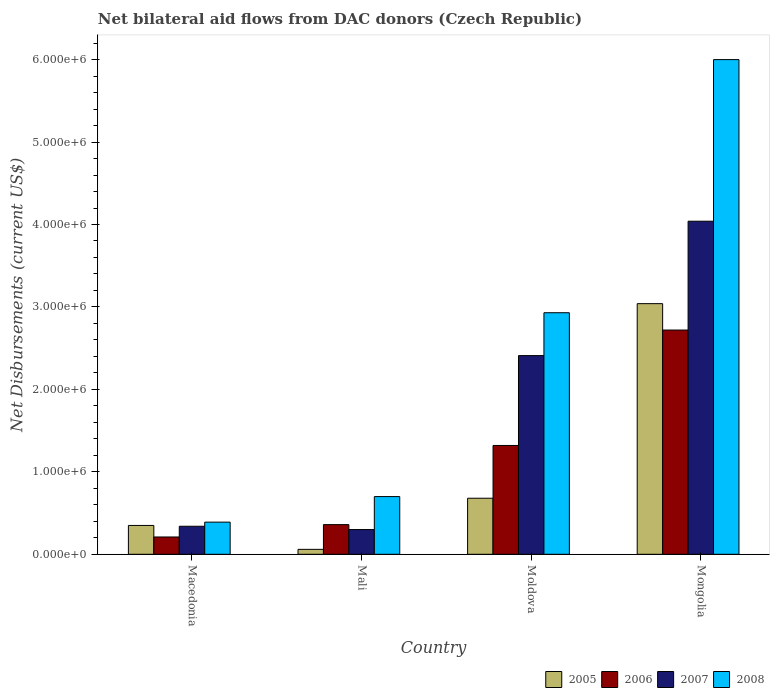How many groups of bars are there?
Give a very brief answer. 4. Are the number of bars per tick equal to the number of legend labels?
Your answer should be compact. Yes. Are the number of bars on each tick of the X-axis equal?
Keep it short and to the point. Yes. How many bars are there on the 1st tick from the left?
Your answer should be very brief. 4. How many bars are there on the 3rd tick from the right?
Ensure brevity in your answer.  4. What is the label of the 2nd group of bars from the left?
Your answer should be very brief. Mali. What is the net bilateral aid flows in 2005 in Macedonia?
Make the answer very short. 3.50e+05. Across all countries, what is the maximum net bilateral aid flows in 2007?
Make the answer very short. 4.04e+06. In which country was the net bilateral aid flows in 2007 maximum?
Your answer should be very brief. Mongolia. In which country was the net bilateral aid flows in 2006 minimum?
Your answer should be compact. Macedonia. What is the total net bilateral aid flows in 2008 in the graph?
Offer a terse response. 1.00e+07. What is the difference between the net bilateral aid flows in 2005 in Moldova and that in Mongolia?
Offer a terse response. -2.36e+06. What is the difference between the net bilateral aid flows in 2007 in Macedonia and the net bilateral aid flows in 2006 in Moldova?
Provide a succinct answer. -9.80e+05. What is the average net bilateral aid flows in 2005 per country?
Ensure brevity in your answer.  1.03e+06. What is the difference between the net bilateral aid flows of/in 2005 and net bilateral aid flows of/in 2006 in Moldova?
Provide a short and direct response. -6.40e+05. In how many countries, is the net bilateral aid flows in 2005 greater than 5600000 US$?
Provide a short and direct response. 0. What is the ratio of the net bilateral aid flows in 2006 in Moldova to that in Mongolia?
Offer a terse response. 0.49. Is the difference between the net bilateral aid flows in 2005 in Macedonia and Mongolia greater than the difference between the net bilateral aid flows in 2006 in Macedonia and Mongolia?
Give a very brief answer. No. What is the difference between the highest and the second highest net bilateral aid flows in 2007?
Your answer should be very brief. 1.63e+06. What is the difference between the highest and the lowest net bilateral aid flows in 2005?
Your answer should be very brief. 2.98e+06. Is the sum of the net bilateral aid flows in 2008 in Mali and Mongolia greater than the maximum net bilateral aid flows in 2006 across all countries?
Provide a short and direct response. Yes. What does the 1st bar from the left in Mongolia represents?
Provide a succinct answer. 2005. Is it the case that in every country, the sum of the net bilateral aid flows in 2006 and net bilateral aid flows in 2005 is greater than the net bilateral aid flows in 2008?
Provide a short and direct response. No. Are all the bars in the graph horizontal?
Provide a succinct answer. No. How many countries are there in the graph?
Your response must be concise. 4. What is the difference between two consecutive major ticks on the Y-axis?
Your answer should be compact. 1.00e+06. Where does the legend appear in the graph?
Your answer should be very brief. Bottom right. How many legend labels are there?
Offer a very short reply. 4. What is the title of the graph?
Offer a terse response. Net bilateral aid flows from DAC donors (Czech Republic). What is the label or title of the Y-axis?
Give a very brief answer. Net Disbursements (current US$). What is the Net Disbursements (current US$) of 2006 in Macedonia?
Your response must be concise. 2.10e+05. What is the Net Disbursements (current US$) in 2005 in Mali?
Your answer should be compact. 6.00e+04. What is the Net Disbursements (current US$) of 2006 in Mali?
Your response must be concise. 3.60e+05. What is the Net Disbursements (current US$) in 2007 in Mali?
Offer a terse response. 3.00e+05. What is the Net Disbursements (current US$) of 2008 in Mali?
Give a very brief answer. 7.00e+05. What is the Net Disbursements (current US$) of 2005 in Moldova?
Offer a very short reply. 6.80e+05. What is the Net Disbursements (current US$) of 2006 in Moldova?
Offer a very short reply. 1.32e+06. What is the Net Disbursements (current US$) in 2007 in Moldova?
Your answer should be compact. 2.41e+06. What is the Net Disbursements (current US$) of 2008 in Moldova?
Your answer should be very brief. 2.93e+06. What is the Net Disbursements (current US$) of 2005 in Mongolia?
Your response must be concise. 3.04e+06. What is the Net Disbursements (current US$) of 2006 in Mongolia?
Provide a short and direct response. 2.72e+06. What is the Net Disbursements (current US$) in 2007 in Mongolia?
Make the answer very short. 4.04e+06. What is the Net Disbursements (current US$) of 2008 in Mongolia?
Provide a short and direct response. 6.00e+06. Across all countries, what is the maximum Net Disbursements (current US$) in 2005?
Your response must be concise. 3.04e+06. Across all countries, what is the maximum Net Disbursements (current US$) in 2006?
Give a very brief answer. 2.72e+06. Across all countries, what is the maximum Net Disbursements (current US$) of 2007?
Keep it short and to the point. 4.04e+06. Across all countries, what is the minimum Net Disbursements (current US$) of 2005?
Your response must be concise. 6.00e+04. Across all countries, what is the minimum Net Disbursements (current US$) of 2007?
Your answer should be very brief. 3.00e+05. Across all countries, what is the minimum Net Disbursements (current US$) in 2008?
Keep it short and to the point. 3.90e+05. What is the total Net Disbursements (current US$) in 2005 in the graph?
Offer a terse response. 4.13e+06. What is the total Net Disbursements (current US$) of 2006 in the graph?
Your answer should be compact. 4.61e+06. What is the total Net Disbursements (current US$) of 2007 in the graph?
Your answer should be compact. 7.09e+06. What is the total Net Disbursements (current US$) in 2008 in the graph?
Provide a short and direct response. 1.00e+07. What is the difference between the Net Disbursements (current US$) of 2007 in Macedonia and that in Mali?
Provide a succinct answer. 4.00e+04. What is the difference between the Net Disbursements (current US$) of 2008 in Macedonia and that in Mali?
Provide a short and direct response. -3.10e+05. What is the difference between the Net Disbursements (current US$) of 2005 in Macedonia and that in Moldova?
Provide a succinct answer. -3.30e+05. What is the difference between the Net Disbursements (current US$) in 2006 in Macedonia and that in Moldova?
Provide a succinct answer. -1.11e+06. What is the difference between the Net Disbursements (current US$) of 2007 in Macedonia and that in Moldova?
Make the answer very short. -2.07e+06. What is the difference between the Net Disbursements (current US$) of 2008 in Macedonia and that in Moldova?
Keep it short and to the point. -2.54e+06. What is the difference between the Net Disbursements (current US$) in 2005 in Macedonia and that in Mongolia?
Ensure brevity in your answer.  -2.69e+06. What is the difference between the Net Disbursements (current US$) in 2006 in Macedonia and that in Mongolia?
Keep it short and to the point. -2.51e+06. What is the difference between the Net Disbursements (current US$) of 2007 in Macedonia and that in Mongolia?
Make the answer very short. -3.70e+06. What is the difference between the Net Disbursements (current US$) in 2008 in Macedonia and that in Mongolia?
Your answer should be compact. -5.61e+06. What is the difference between the Net Disbursements (current US$) in 2005 in Mali and that in Moldova?
Ensure brevity in your answer.  -6.20e+05. What is the difference between the Net Disbursements (current US$) of 2006 in Mali and that in Moldova?
Your answer should be very brief. -9.60e+05. What is the difference between the Net Disbursements (current US$) in 2007 in Mali and that in Moldova?
Provide a short and direct response. -2.11e+06. What is the difference between the Net Disbursements (current US$) of 2008 in Mali and that in Moldova?
Your answer should be compact. -2.23e+06. What is the difference between the Net Disbursements (current US$) in 2005 in Mali and that in Mongolia?
Keep it short and to the point. -2.98e+06. What is the difference between the Net Disbursements (current US$) of 2006 in Mali and that in Mongolia?
Your answer should be very brief. -2.36e+06. What is the difference between the Net Disbursements (current US$) of 2007 in Mali and that in Mongolia?
Provide a short and direct response. -3.74e+06. What is the difference between the Net Disbursements (current US$) of 2008 in Mali and that in Mongolia?
Provide a succinct answer. -5.30e+06. What is the difference between the Net Disbursements (current US$) in 2005 in Moldova and that in Mongolia?
Provide a short and direct response. -2.36e+06. What is the difference between the Net Disbursements (current US$) of 2006 in Moldova and that in Mongolia?
Give a very brief answer. -1.40e+06. What is the difference between the Net Disbursements (current US$) in 2007 in Moldova and that in Mongolia?
Ensure brevity in your answer.  -1.63e+06. What is the difference between the Net Disbursements (current US$) in 2008 in Moldova and that in Mongolia?
Your answer should be very brief. -3.07e+06. What is the difference between the Net Disbursements (current US$) in 2005 in Macedonia and the Net Disbursements (current US$) in 2008 in Mali?
Give a very brief answer. -3.50e+05. What is the difference between the Net Disbursements (current US$) of 2006 in Macedonia and the Net Disbursements (current US$) of 2008 in Mali?
Keep it short and to the point. -4.90e+05. What is the difference between the Net Disbursements (current US$) of 2007 in Macedonia and the Net Disbursements (current US$) of 2008 in Mali?
Ensure brevity in your answer.  -3.60e+05. What is the difference between the Net Disbursements (current US$) of 2005 in Macedonia and the Net Disbursements (current US$) of 2006 in Moldova?
Your response must be concise. -9.70e+05. What is the difference between the Net Disbursements (current US$) in 2005 in Macedonia and the Net Disbursements (current US$) in 2007 in Moldova?
Your answer should be very brief. -2.06e+06. What is the difference between the Net Disbursements (current US$) in 2005 in Macedonia and the Net Disbursements (current US$) in 2008 in Moldova?
Offer a very short reply. -2.58e+06. What is the difference between the Net Disbursements (current US$) in 2006 in Macedonia and the Net Disbursements (current US$) in 2007 in Moldova?
Provide a succinct answer. -2.20e+06. What is the difference between the Net Disbursements (current US$) of 2006 in Macedonia and the Net Disbursements (current US$) of 2008 in Moldova?
Keep it short and to the point. -2.72e+06. What is the difference between the Net Disbursements (current US$) of 2007 in Macedonia and the Net Disbursements (current US$) of 2008 in Moldova?
Give a very brief answer. -2.59e+06. What is the difference between the Net Disbursements (current US$) in 2005 in Macedonia and the Net Disbursements (current US$) in 2006 in Mongolia?
Your response must be concise. -2.37e+06. What is the difference between the Net Disbursements (current US$) of 2005 in Macedonia and the Net Disbursements (current US$) of 2007 in Mongolia?
Your answer should be compact. -3.69e+06. What is the difference between the Net Disbursements (current US$) in 2005 in Macedonia and the Net Disbursements (current US$) in 2008 in Mongolia?
Your answer should be compact. -5.65e+06. What is the difference between the Net Disbursements (current US$) in 2006 in Macedonia and the Net Disbursements (current US$) in 2007 in Mongolia?
Your answer should be compact. -3.83e+06. What is the difference between the Net Disbursements (current US$) in 2006 in Macedonia and the Net Disbursements (current US$) in 2008 in Mongolia?
Keep it short and to the point. -5.79e+06. What is the difference between the Net Disbursements (current US$) of 2007 in Macedonia and the Net Disbursements (current US$) of 2008 in Mongolia?
Offer a terse response. -5.66e+06. What is the difference between the Net Disbursements (current US$) of 2005 in Mali and the Net Disbursements (current US$) of 2006 in Moldova?
Provide a short and direct response. -1.26e+06. What is the difference between the Net Disbursements (current US$) in 2005 in Mali and the Net Disbursements (current US$) in 2007 in Moldova?
Offer a very short reply. -2.35e+06. What is the difference between the Net Disbursements (current US$) in 2005 in Mali and the Net Disbursements (current US$) in 2008 in Moldova?
Make the answer very short. -2.87e+06. What is the difference between the Net Disbursements (current US$) of 2006 in Mali and the Net Disbursements (current US$) of 2007 in Moldova?
Make the answer very short. -2.05e+06. What is the difference between the Net Disbursements (current US$) in 2006 in Mali and the Net Disbursements (current US$) in 2008 in Moldova?
Your answer should be compact. -2.57e+06. What is the difference between the Net Disbursements (current US$) of 2007 in Mali and the Net Disbursements (current US$) of 2008 in Moldova?
Make the answer very short. -2.63e+06. What is the difference between the Net Disbursements (current US$) in 2005 in Mali and the Net Disbursements (current US$) in 2006 in Mongolia?
Your answer should be compact. -2.66e+06. What is the difference between the Net Disbursements (current US$) in 2005 in Mali and the Net Disbursements (current US$) in 2007 in Mongolia?
Make the answer very short. -3.98e+06. What is the difference between the Net Disbursements (current US$) of 2005 in Mali and the Net Disbursements (current US$) of 2008 in Mongolia?
Your answer should be compact. -5.94e+06. What is the difference between the Net Disbursements (current US$) of 2006 in Mali and the Net Disbursements (current US$) of 2007 in Mongolia?
Provide a succinct answer. -3.68e+06. What is the difference between the Net Disbursements (current US$) of 2006 in Mali and the Net Disbursements (current US$) of 2008 in Mongolia?
Offer a terse response. -5.64e+06. What is the difference between the Net Disbursements (current US$) in 2007 in Mali and the Net Disbursements (current US$) in 2008 in Mongolia?
Your response must be concise. -5.70e+06. What is the difference between the Net Disbursements (current US$) in 2005 in Moldova and the Net Disbursements (current US$) in 2006 in Mongolia?
Your answer should be very brief. -2.04e+06. What is the difference between the Net Disbursements (current US$) of 2005 in Moldova and the Net Disbursements (current US$) of 2007 in Mongolia?
Keep it short and to the point. -3.36e+06. What is the difference between the Net Disbursements (current US$) in 2005 in Moldova and the Net Disbursements (current US$) in 2008 in Mongolia?
Your answer should be very brief. -5.32e+06. What is the difference between the Net Disbursements (current US$) of 2006 in Moldova and the Net Disbursements (current US$) of 2007 in Mongolia?
Provide a succinct answer. -2.72e+06. What is the difference between the Net Disbursements (current US$) of 2006 in Moldova and the Net Disbursements (current US$) of 2008 in Mongolia?
Give a very brief answer. -4.68e+06. What is the difference between the Net Disbursements (current US$) of 2007 in Moldova and the Net Disbursements (current US$) of 2008 in Mongolia?
Ensure brevity in your answer.  -3.59e+06. What is the average Net Disbursements (current US$) of 2005 per country?
Your response must be concise. 1.03e+06. What is the average Net Disbursements (current US$) of 2006 per country?
Provide a succinct answer. 1.15e+06. What is the average Net Disbursements (current US$) of 2007 per country?
Provide a succinct answer. 1.77e+06. What is the average Net Disbursements (current US$) of 2008 per country?
Offer a very short reply. 2.50e+06. What is the difference between the Net Disbursements (current US$) in 2005 and Net Disbursements (current US$) in 2006 in Macedonia?
Provide a succinct answer. 1.40e+05. What is the difference between the Net Disbursements (current US$) in 2005 and Net Disbursements (current US$) in 2008 in Macedonia?
Your response must be concise. -4.00e+04. What is the difference between the Net Disbursements (current US$) of 2005 and Net Disbursements (current US$) of 2008 in Mali?
Offer a terse response. -6.40e+05. What is the difference between the Net Disbursements (current US$) in 2006 and Net Disbursements (current US$) in 2007 in Mali?
Offer a very short reply. 6.00e+04. What is the difference between the Net Disbursements (current US$) in 2006 and Net Disbursements (current US$) in 2008 in Mali?
Give a very brief answer. -3.40e+05. What is the difference between the Net Disbursements (current US$) in 2007 and Net Disbursements (current US$) in 2008 in Mali?
Your answer should be very brief. -4.00e+05. What is the difference between the Net Disbursements (current US$) in 2005 and Net Disbursements (current US$) in 2006 in Moldova?
Keep it short and to the point. -6.40e+05. What is the difference between the Net Disbursements (current US$) in 2005 and Net Disbursements (current US$) in 2007 in Moldova?
Your answer should be very brief. -1.73e+06. What is the difference between the Net Disbursements (current US$) of 2005 and Net Disbursements (current US$) of 2008 in Moldova?
Your answer should be very brief. -2.25e+06. What is the difference between the Net Disbursements (current US$) of 2006 and Net Disbursements (current US$) of 2007 in Moldova?
Your answer should be very brief. -1.09e+06. What is the difference between the Net Disbursements (current US$) in 2006 and Net Disbursements (current US$) in 2008 in Moldova?
Your response must be concise. -1.61e+06. What is the difference between the Net Disbursements (current US$) of 2007 and Net Disbursements (current US$) of 2008 in Moldova?
Keep it short and to the point. -5.20e+05. What is the difference between the Net Disbursements (current US$) in 2005 and Net Disbursements (current US$) in 2007 in Mongolia?
Make the answer very short. -1.00e+06. What is the difference between the Net Disbursements (current US$) of 2005 and Net Disbursements (current US$) of 2008 in Mongolia?
Make the answer very short. -2.96e+06. What is the difference between the Net Disbursements (current US$) of 2006 and Net Disbursements (current US$) of 2007 in Mongolia?
Provide a succinct answer. -1.32e+06. What is the difference between the Net Disbursements (current US$) in 2006 and Net Disbursements (current US$) in 2008 in Mongolia?
Give a very brief answer. -3.28e+06. What is the difference between the Net Disbursements (current US$) of 2007 and Net Disbursements (current US$) of 2008 in Mongolia?
Give a very brief answer. -1.96e+06. What is the ratio of the Net Disbursements (current US$) of 2005 in Macedonia to that in Mali?
Make the answer very short. 5.83. What is the ratio of the Net Disbursements (current US$) in 2006 in Macedonia to that in Mali?
Keep it short and to the point. 0.58. What is the ratio of the Net Disbursements (current US$) in 2007 in Macedonia to that in Mali?
Give a very brief answer. 1.13. What is the ratio of the Net Disbursements (current US$) in 2008 in Macedonia to that in Mali?
Ensure brevity in your answer.  0.56. What is the ratio of the Net Disbursements (current US$) in 2005 in Macedonia to that in Moldova?
Offer a terse response. 0.51. What is the ratio of the Net Disbursements (current US$) of 2006 in Macedonia to that in Moldova?
Provide a succinct answer. 0.16. What is the ratio of the Net Disbursements (current US$) of 2007 in Macedonia to that in Moldova?
Your answer should be very brief. 0.14. What is the ratio of the Net Disbursements (current US$) in 2008 in Macedonia to that in Moldova?
Your answer should be very brief. 0.13. What is the ratio of the Net Disbursements (current US$) in 2005 in Macedonia to that in Mongolia?
Your response must be concise. 0.12. What is the ratio of the Net Disbursements (current US$) in 2006 in Macedonia to that in Mongolia?
Your response must be concise. 0.08. What is the ratio of the Net Disbursements (current US$) of 2007 in Macedonia to that in Mongolia?
Provide a short and direct response. 0.08. What is the ratio of the Net Disbursements (current US$) of 2008 in Macedonia to that in Mongolia?
Keep it short and to the point. 0.07. What is the ratio of the Net Disbursements (current US$) of 2005 in Mali to that in Moldova?
Keep it short and to the point. 0.09. What is the ratio of the Net Disbursements (current US$) of 2006 in Mali to that in Moldova?
Give a very brief answer. 0.27. What is the ratio of the Net Disbursements (current US$) of 2007 in Mali to that in Moldova?
Give a very brief answer. 0.12. What is the ratio of the Net Disbursements (current US$) of 2008 in Mali to that in Moldova?
Give a very brief answer. 0.24. What is the ratio of the Net Disbursements (current US$) of 2005 in Mali to that in Mongolia?
Your answer should be very brief. 0.02. What is the ratio of the Net Disbursements (current US$) of 2006 in Mali to that in Mongolia?
Provide a short and direct response. 0.13. What is the ratio of the Net Disbursements (current US$) of 2007 in Mali to that in Mongolia?
Provide a short and direct response. 0.07. What is the ratio of the Net Disbursements (current US$) of 2008 in Mali to that in Mongolia?
Give a very brief answer. 0.12. What is the ratio of the Net Disbursements (current US$) of 2005 in Moldova to that in Mongolia?
Your response must be concise. 0.22. What is the ratio of the Net Disbursements (current US$) of 2006 in Moldova to that in Mongolia?
Your response must be concise. 0.49. What is the ratio of the Net Disbursements (current US$) of 2007 in Moldova to that in Mongolia?
Your answer should be very brief. 0.6. What is the ratio of the Net Disbursements (current US$) in 2008 in Moldova to that in Mongolia?
Your response must be concise. 0.49. What is the difference between the highest and the second highest Net Disbursements (current US$) in 2005?
Provide a succinct answer. 2.36e+06. What is the difference between the highest and the second highest Net Disbursements (current US$) in 2006?
Keep it short and to the point. 1.40e+06. What is the difference between the highest and the second highest Net Disbursements (current US$) in 2007?
Provide a short and direct response. 1.63e+06. What is the difference between the highest and the second highest Net Disbursements (current US$) of 2008?
Offer a very short reply. 3.07e+06. What is the difference between the highest and the lowest Net Disbursements (current US$) in 2005?
Offer a very short reply. 2.98e+06. What is the difference between the highest and the lowest Net Disbursements (current US$) in 2006?
Your response must be concise. 2.51e+06. What is the difference between the highest and the lowest Net Disbursements (current US$) of 2007?
Provide a succinct answer. 3.74e+06. What is the difference between the highest and the lowest Net Disbursements (current US$) in 2008?
Your answer should be very brief. 5.61e+06. 